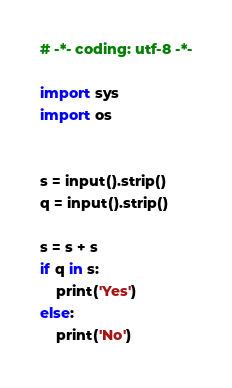Convert code to text. <code><loc_0><loc_0><loc_500><loc_500><_Python_># -*- coding: utf-8 -*-

import sys
import os


s = input().strip()
q = input().strip()

s = s + s
if q in s:
    print('Yes')
else:
    print('No')</code> 